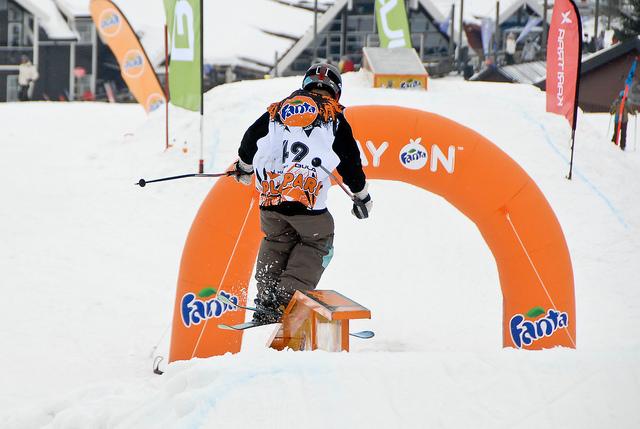Is coca cola shown as a sponsor?
Write a very short answer. No. What soda is advertised?
Short answer required. Fanta. What sport is this?
Quick response, please. Skiing. 